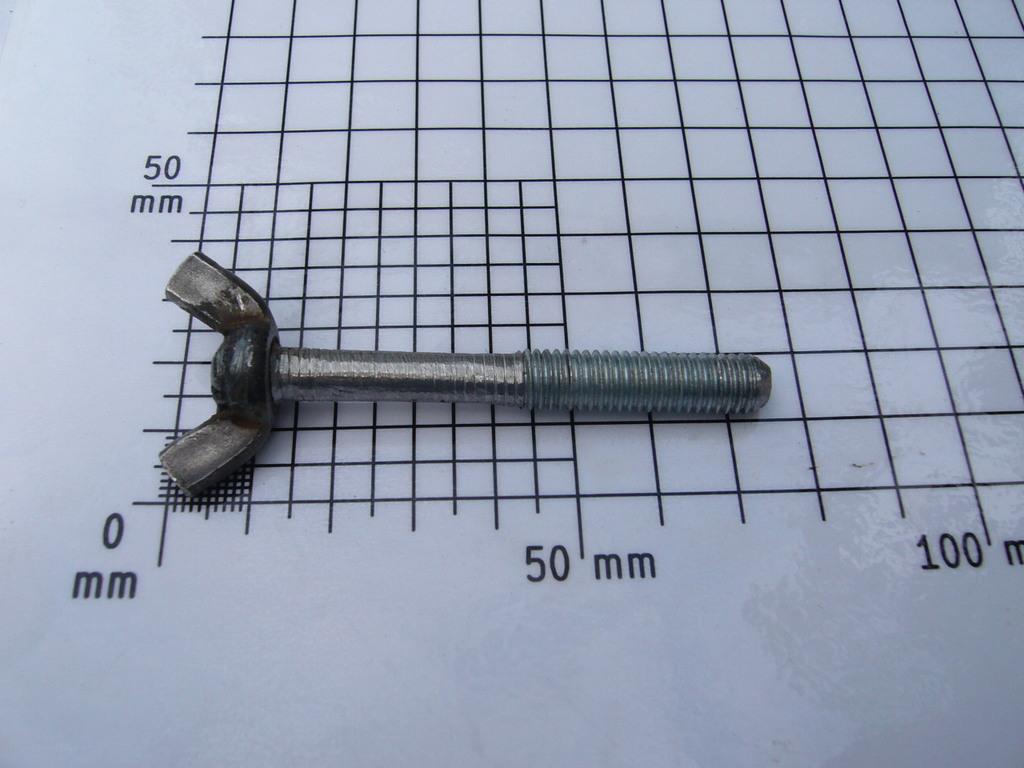How many mm on the bottom left corner?
Offer a very short reply. 0. 